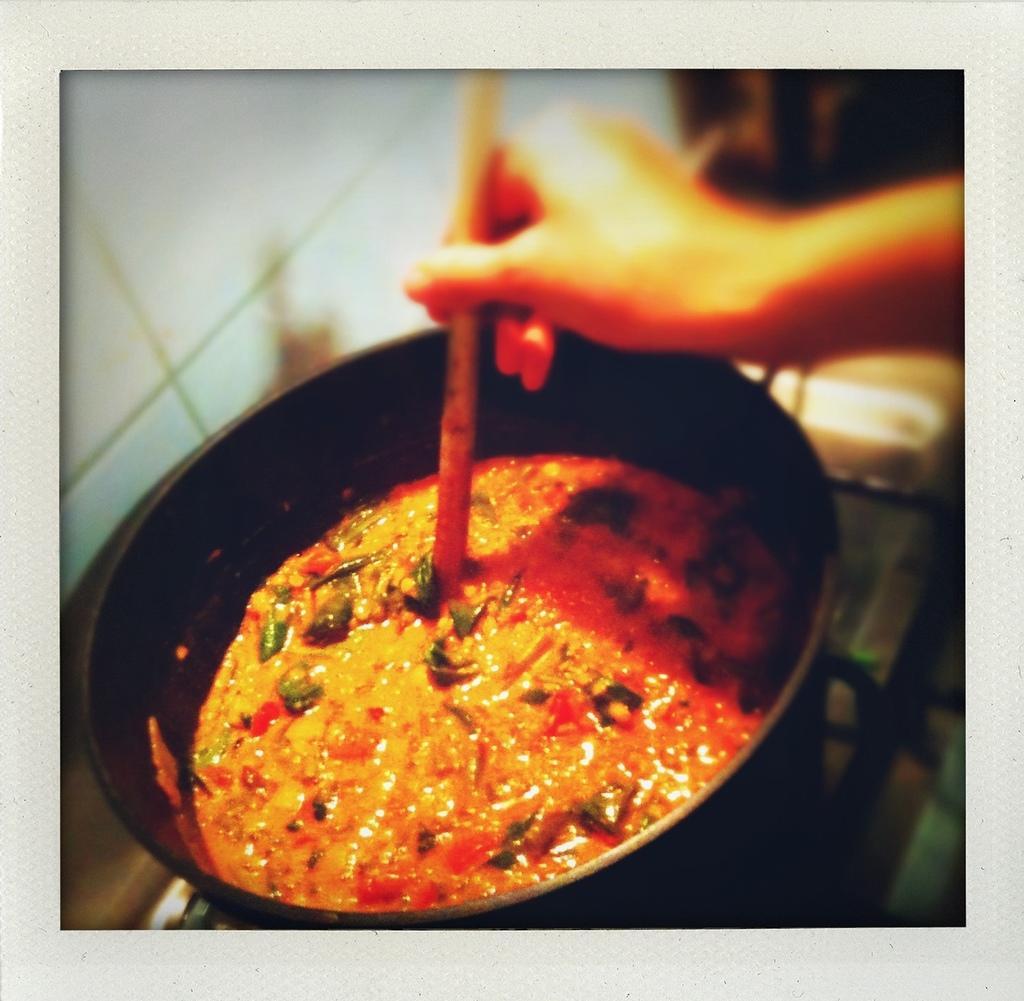Please provide a concise description of this image. In this picture there is a pan in the center of the image, which contains curry in it and there is a hand, by holding a spoon at the top side of the image. 